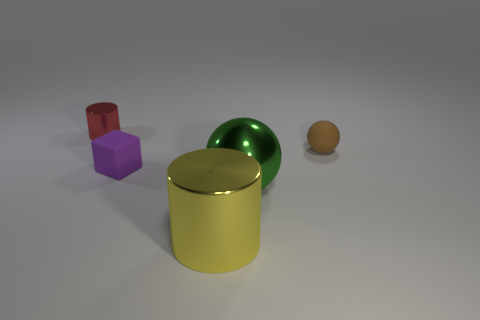Add 3 large green metallic things. How many objects exist? 8 Subtract 0 yellow blocks. How many objects are left? 5 Subtract all spheres. How many objects are left? 3 Subtract 1 cubes. How many cubes are left? 0 Subtract all yellow cylinders. Subtract all gray spheres. How many cylinders are left? 1 Subtract all gray balls. How many red cylinders are left? 1 Subtract all large cylinders. Subtract all purple matte cubes. How many objects are left? 3 Add 1 brown balls. How many brown balls are left? 2 Add 5 purple shiny spheres. How many purple shiny spheres exist? 5 